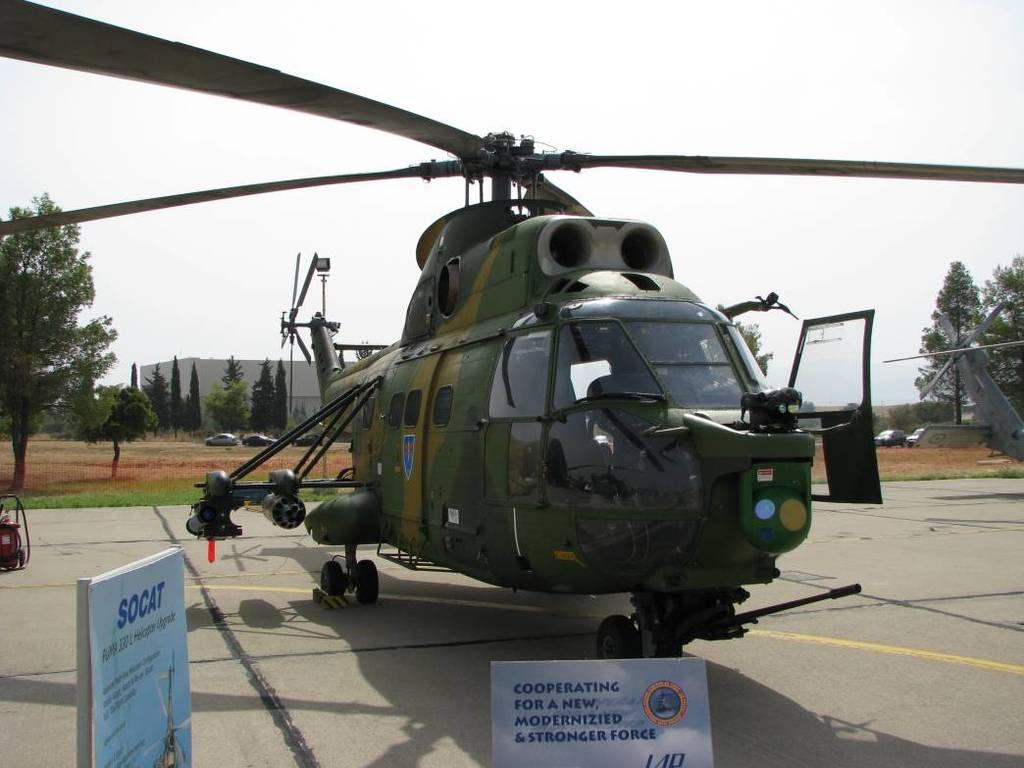What does the sign say?
Keep it short and to the point. Cooperating for a new modernized and stronger force. What does the sign on the left say?
Provide a succinct answer. Socat. 